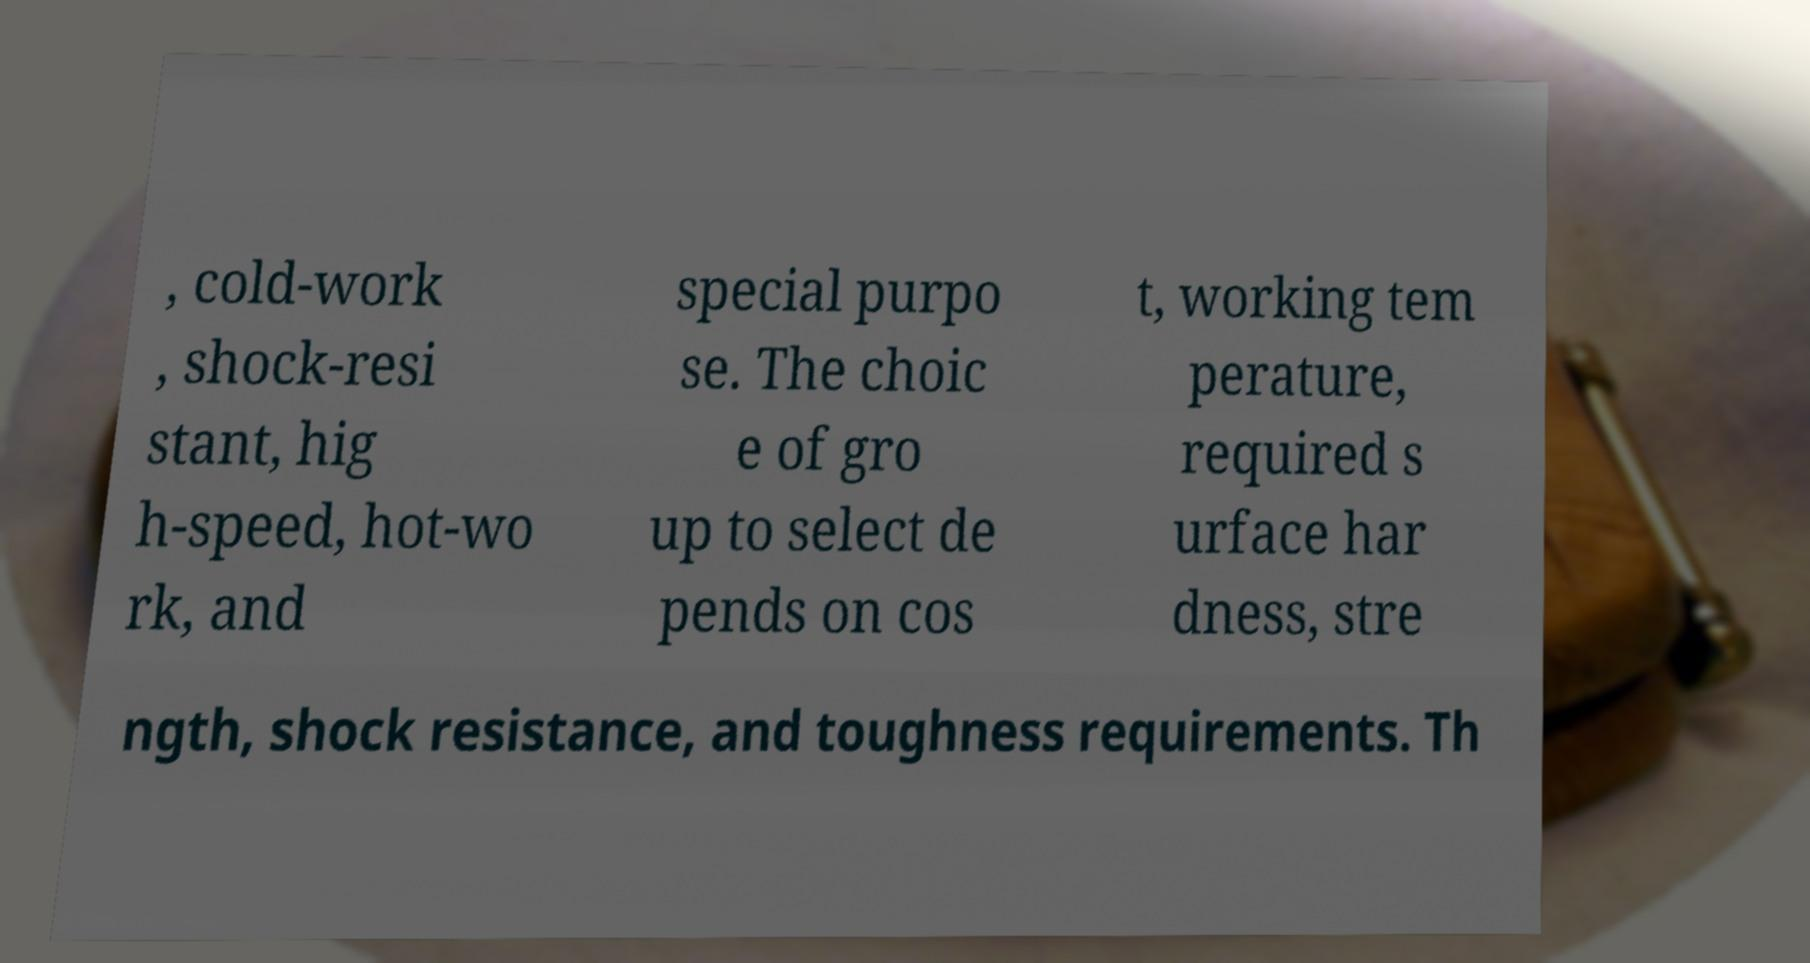Can you accurately transcribe the text from the provided image for me? , cold-work , shock-resi stant, hig h-speed, hot-wo rk, and special purpo se. The choic e of gro up to select de pends on cos t, working tem perature, required s urface har dness, stre ngth, shock resistance, and toughness requirements. Th 